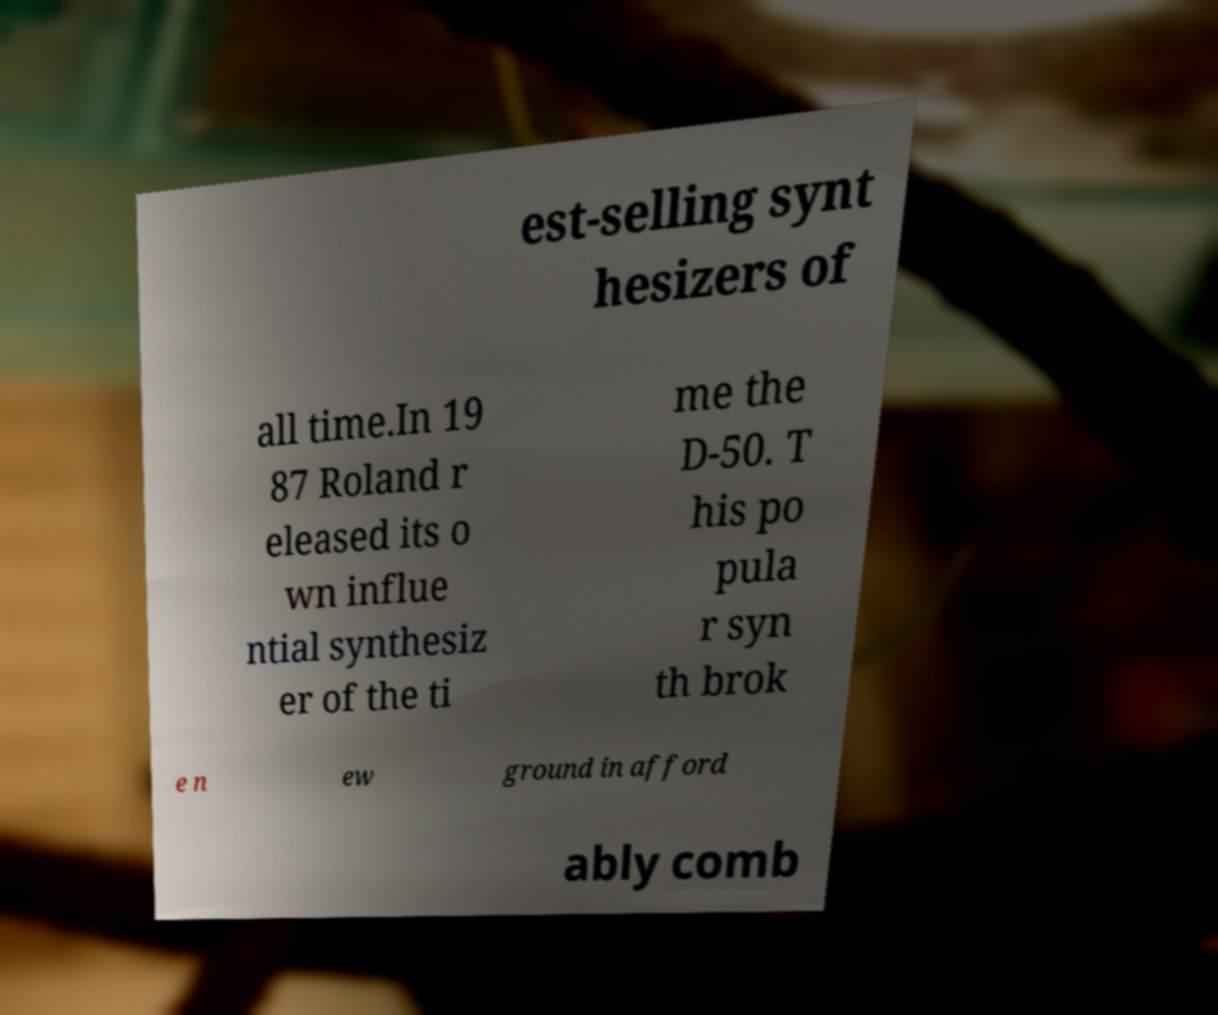Can you read and provide the text displayed in the image?This photo seems to have some interesting text. Can you extract and type it out for me? est-selling synt hesizers of all time.In 19 87 Roland r eleased its o wn influe ntial synthesiz er of the ti me the D-50. T his po pula r syn th brok e n ew ground in afford ably comb 